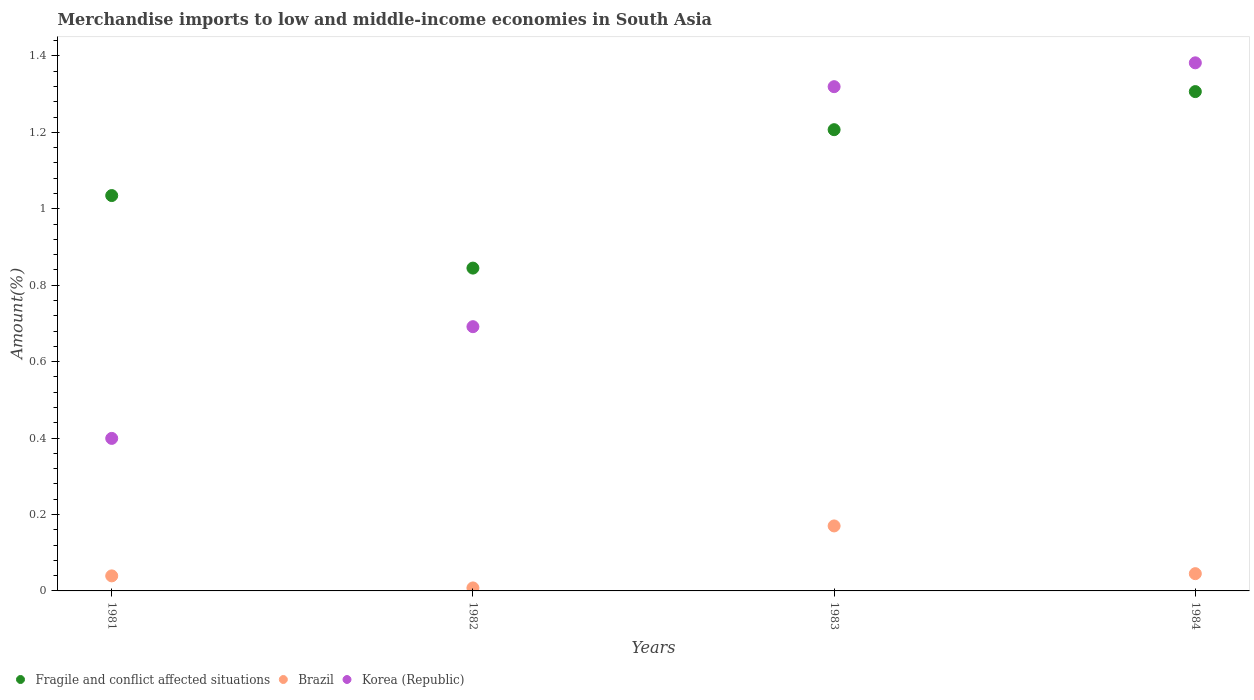What is the percentage of amount earned from merchandise imports in Brazil in 1984?
Offer a terse response. 0.05. Across all years, what is the maximum percentage of amount earned from merchandise imports in Korea (Republic)?
Your answer should be compact. 1.38. Across all years, what is the minimum percentage of amount earned from merchandise imports in Korea (Republic)?
Offer a very short reply. 0.4. In which year was the percentage of amount earned from merchandise imports in Brazil maximum?
Offer a terse response. 1983. What is the total percentage of amount earned from merchandise imports in Fragile and conflict affected situations in the graph?
Make the answer very short. 4.39. What is the difference between the percentage of amount earned from merchandise imports in Fragile and conflict affected situations in 1981 and that in 1984?
Your answer should be compact. -0.27. What is the difference between the percentage of amount earned from merchandise imports in Brazil in 1984 and the percentage of amount earned from merchandise imports in Fragile and conflict affected situations in 1981?
Your response must be concise. -0.99. What is the average percentage of amount earned from merchandise imports in Brazil per year?
Provide a succinct answer. 0.07. In the year 1981, what is the difference between the percentage of amount earned from merchandise imports in Korea (Republic) and percentage of amount earned from merchandise imports in Fragile and conflict affected situations?
Your answer should be very brief. -0.64. In how many years, is the percentage of amount earned from merchandise imports in Brazil greater than 1.16 %?
Make the answer very short. 0. What is the ratio of the percentage of amount earned from merchandise imports in Brazil in 1982 to that in 1984?
Keep it short and to the point. 0.17. Is the percentage of amount earned from merchandise imports in Fragile and conflict affected situations in 1981 less than that in 1982?
Provide a short and direct response. No. Is the difference between the percentage of amount earned from merchandise imports in Korea (Republic) in 1983 and 1984 greater than the difference between the percentage of amount earned from merchandise imports in Fragile and conflict affected situations in 1983 and 1984?
Keep it short and to the point. Yes. What is the difference between the highest and the second highest percentage of amount earned from merchandise imports in Fragile and conflict affected situations?
Give a very brief answer. 0.1. What is the difference between the highest and the lowest percentage of amount earned from merchandise imports in Fragile and conflict affected situations?
Keep it short and to the point. 0.46. Is the sum of the percentage of amount earned from merchandise imports in Fragile and conflict affected situations in 1983 and 1984 greater than the maximum percentage of amount earned from merchandise imports in Brazil across all years?
Offer a very short reply. Yes. Is it the case that in every year, the sum of the percentage of amount earned from merchandise imports in Fragile and conflict affected situations and percentage of amount earned from merchandise imports in Korea (Republic)  is greater than the percentage of amount earned from merchandise imports in Brazil?
Ensure brevity in your answer.  Yes. Is the percentage of amount earned from merchandise imports in Brazil strictly less than the percentage of amount earned from merchandise imports in Fragile and conflict affected situations over the years?
Offer a terse response. Yes. Does the graph contain any zero values?
Your answer should be very brief. No. Where does the legend appear in the graph?
Ensure brevity in your answer.  Bottom left. How many legend labels are there?
Give a very brief answer. 3. What is the title of the graph?
Provide a short and direct response. Merchandise imports to low and middle-income economies in South Asia. Does "Thailand" appear as one of the legend labels in the graph?
Make the answer very short. No. What is the label or title of the Y-axis?
Provide a succinct answer. Amount(%). What is the Amount(%) in Fragile and conflict affected situations in 1981?
Provide a succinct answer. 1.03. What is the Amount(%) in Brazil in 1981?
Provide a succinct answer. 0.04. What is the Amount(%) in Korea (Republic) in 1981?
Make the answer very short. 0.4. What is the Amount(%) of Fragile and conflict affected situations in 1982?
Your answer should be very brief. 0.84. What is the Amount(%) in Brazil in 1982?
Your answer should be very brief. 0.01. What is the Amount(%) of Korea (Republic) in 1982?
Give a very brief answer. 0.69. What is the Amount(%) in Fragile and conflict affected situations in 1983?
Provide a short and direct response. 1.21. What is the Amount(%) of Brazil in 1983?
Make the answer very short. 0.17. What is the Amount(%) in Korea (Republic) in 1983?
Your answer should be very brief. 1.32. What is the Amount(%) in Fragile and conflict affected situations in 1984?
Your response must be concise. 1.31. What is the Amount(%) of Brazil in 1984?
Your answer should be very brief. 0.05. What is the Amount(%) in Korea (Republic) in 1984?
Offer a terse response. 1.38. Across all years, what is the maximum Amount(%) in Fragile and conflict affected situations?
Offer a terse response. 1.31. Across all years, what is the maximum Amount(%) in Brazil?
Offer a very short reply. 0.17. Across all years, what is the maximum Amount(%) in Korea (Republic)?
Make the answer very short. 1.38. Across all years, what is the minimum Amount(%) of Fragile and conflict affected situations?
Ensure brevity in your answer.  0.84. Across all years, what is the minimum Amount(%) in Brazil?
Your answer should be very brief. 0.01. Across all years, what is the minimum Amount(%) in Korea (Republic)?
Keep it short and to the point. 0.4. What is the total Amount(%) of Fragile and conflict affected situations in the graph?
Ensure brevity in your answer.  4.39. What is the total Amount(%) in Brazil in the graph?
Your answer should be very brief. 0.26. What is the total Amount(%) in Korea (Republic) in the graph?
Provide a short and direct response. 3.79. What is the difference between the Amount(%) of Fragile and conflict affected situations in 1981 and that in 1982?
Ensure brevity in your answer.  0.19. What is the difference between the Amount(%) in Brazil in 1981 and that in 1982?
Your answer should be compact. 0.03. What is the difference between the Amount(%) of Korea (Republic) in 1981 and that in 1982?
Provide a short and direct response. -0.29. What is the difference between the Amount(%) in Fragile and conflict affected situations in 1981 and that in 1983?
Give a very brief answer. -0.17. What is the difference between the Amount(%) in Brazil in 1981 and that in 1983?
Offer a very short reply. -0.13. What is the difference between the Amount(%) in Korea (Republic) in 1981 and that in 1983?
Ensure brevity in your answer.  -0.92. What is the difference between the Amount(%) in Fragile and conflict affected situations in 1981 and that in 1984?
Make the answer very short. -0.27. What is the difference between the Amount(%) in Brazil in 1981 and that in 1984?
Offer a terse response. -0.01. What is the difference between the Amount(%) of Korea (Republic) in 1981 and that in 1984?
Ensure brevity in your answer.  -0.98. What is the difference between the Amount(%) of Fragile and conflict affected situations in 1982 and that in 1983?
Offer a terse response. -0.36. What is the difference between the Amount(%) of Brazil in 1982 and that in 1983?
Offer a very short reply. -0.16. What is the difference between the Amount(%) in Korea (Republic) in 1982 and that in 1983?
Your answer should be compact. -0.63. What is the difference between the Amount(%) of Fragile and conflict affected situations in 1982 and that in 1984?
Ensure brevity in your answer.  -0.46. What is the difference between the Amount(%) of Brazil in 1982 and that in 1984?
Ensure brevity in your answer.  -0.04. What is the difference between the Amount(%) of Korea (Republic) in 1982 and that in 1984?
Give a very brief answer. -0.69. What is the difference between the Amount(%) of Fragile and conflict affected situations in 1983 and that in 1984?
Offer a very short reply. -0.1. What is the difference between the Amount(%) in Brazil in 1983 and that in 1984?
Offer a very short reply. 0.12. What is the difference between the Amount(%) in Korea (Republic) in 1983 and that in 1984?
Give a very brief answer. -0.06. What is the difference between the Amount(%) in Fragile and conflict affected situations in 1981 and the Amount(%) in Brazil in 1982?
Provide a succinct answer. 1.03. What is the difference between the Amount(%) of Fragile and conflict affected situations in 1981 and the Amount(%) of Korea (Republic) in 1982?
Offer a terse response. 0.34. What is the difference between the Amount(%) in Brazil in 1981 and the Amount(%) in Korea (Republic) in 1982?
Keep it short and to the point. -0.65. What is the difference between the Amount(%) in Fragile and conflict affected situations in 1981 and the Amount(%) in Brazil in 1983?
Your answer should be compact. 0.86. What is the difference between the Amount(%) in Fragile and conflict affected situations in 1981 and the Amount(%) in Korea (Republic) in 1983?
Make the answer very short. -0.28. What is the difference between the Amount(%) in Brazil in 1981 and the Amount(%) in Korea (Republic) in 1983?
Make the answer very short. -1.28. What is the difference between the Amount(%) in Fragile and conflict affected situations in 1981 and the Amount(%) in Brazil in 1984?
Ensure brevity in your answer.  0.99. What is the difference between the Amount(%) of Fragile and conflict affected situations in 1981 and the Amount(%) of Korea (Republic) in 1984?
Your answer should be very brief. -0.35. What is the difference between the Amount(%) in Brazil in 1981 and the Amount(%) in Korea (Republic) in 1984?
Offer a very short reply. -1.34. What is the difference between the Amount(%) of Fragile and conflict affected situations in 1982 and the Amount(%) of Brazil in 1983?
Offer a terse response. 0.67. What is the difference between the Amount(%) in Fragile and conflict affected situations in 1982 and the Amount(%) in Korea (Republic) in 1983?
Provide a short and direct response. -0.47. What is the difference between the Amount(%) of Brazil in 1982 and the Amount(%) of Korea (Republic) in 1983?
Provide a short and direct response. -1.31. What is the difference between the Amount(%) of Fragile and conflict affected situations in 1982 and the Amount(%) of Brazil in 1984?
Provide a succinct answer. 0.8. What is the difference between the Amount(%) of Fragile and conflict affected situations in 1982 and the Amount(%) of Korea (Republic) in 1984?
Give a very brief answer. -0.54. What is the difference between the Amount(%) of Brazil in 1982 and the Amount(%) of Korea (Republic) in 1984?
Ensure brevity in your answer.  -1.37. What is the difference between the Amount(%) of Fragile and conflict affected situations in 1983 and the Amount(%) of Brazil in 1984?
Offer a very short reply. 1.16. What is the difference between the Amount(%) in Fragile and conflict affected situations in 1983 and the Amount(%) in Korea (Republic) in 1984?
Make the answer very short. -0.17. What is the difference between the Amount(%) of Brazil in 1983 and the Amount(%) of Korea (Republic) in 1984?
Your answer should be compact. -1.21. What is the average Amount(%) in Fragile and conflict affected situations per year?
Your answer should be compact. 1.1. What is the average Amount(%) in Brazil per year?
Your response must be concise. 0.07. What is the average Amount(%) of Korea (Republic) per year?
Your response must be concise. 0.95. In the year 1981, what is the difference between the Amount(%) in Fragile and conflict affected situations and Amount(%) in Brazil?
Ensure brevity in your answer.  1. In the year 1981, what is the difference between the Amount(%) of Fragile and conflict affected situations and Amount(%) of Korea (Republic)?
Make the answer very short. 0.64. In the year 1981, what is the difference between the Amount(%) of Brazil and Amount(%) of Korea (Republic)?
Make the answer very short. -0.36. In the year 1982, what is the difference between the Amount(%) in Fragile and conflict affected situations and Amount(%) in Brazil?
Provide a short and direct response. 0.84. In the year 1982, what is the difference between the Amount(%) in Fragile and conflict affected situations and Amount(%) in Korea (Republic)?
Offer a terse response. 0.15. In the year 1982, what is the difference between the Amount(%) in Brazil and Amount(%) in Korea (Republic)?
Provide a short and direct response. -0.68. In the year 1983, what is the difference between the Amount(%) of Fragile and conflict affected situations and Amount(%) of Korea (Republic)?
Provide a short and direct response. -0.11. In the year 1983, what is the difference between the Amount(%) of Brazil and Amount(%) of Korea (Republic)?
Your answer should be very brief. -1.15. In the year 1984, what is the difference between the Amount(%) of Fragile and conflict affected situations and Amount(%) of Brazil?
Provide a short and direct response. 1.26. In the year 1984, what is the difference between the Amount(%) of Fragile and conflict affected situations and Amount(%) of Korea (Republic)?
Provide a short and direct response. -0.08. In the year 1984, what is the difference between the Amount(%) in Brazil and Amount(%) in Korea (Republic)?
Keep it short and to the point. -1.34. What is the ratio of the Amount(%) in Fragile and conflict affected situations in 1981 to that in 1982?
Provide a short and direct response. 1.22. What is the ratio of the Amount(%) in Brazil in 1981 to that in 1982?
Your response must be concise. 5.03. What is the ratio of the Amount(%) in Korea (Republic) in 1981 to that in 1982?
Make the answer very short. 0.58. What is the ratio of the Amount(%) in Fragile and conflict affected situations in 1981 to that in 1983?
Your response must be concise. 0.86. What is the ratio of the Amount(%) in Brazil in 1981 to that in 1983?
Your answer should be very brief. 0.23. What is the ratio of the Amount(%) of Korea (Republic) in 1981 to that in 1983?
Your answer should be very brief. 0.3. What is the ratio of the Amount(%) of Fragile and conflict affected situations in 1981 to that in 1984?
Your response must be concise. 0.79. What is the ratio of the Amount(%) in Brazil in 1981 to that in 1984?
Keep it short and to the point. 0.87. What is the ratio of the Amount(%) in Korea (Republic) in 1981 to that in 1984?
Make the answer very short. 0.29. What is the ratio of the Amount(%) in Fragile and conflict affected situations in 1982 to that in 1983?
Offer a very short reply. 0.7. What is the ratio of the Amount(%) of Brazil in 1982 to that in 1983?
Your response must be concise. 0.05. What is the ratio of the Amount(%) in Korea (Republic) in 1982 to that in 1983?
Offer a terse response. 0.52. What is the ratio of the Amount(%) in Fragile and conflict affected situations in 1982 to that in 1984?
Give a very brief answer. 0.65. What is the ratio of the Amount(%) in Brazil in 1982 to that in 1984?
Keep it short and to the point. 0.17. What is the ratio of the Amount(%) of Korea (Republic) in 1982 to that in 1984?
Your answer should be compact. 0.5. What is the ratio of the Amount(%) of Fragile and conflict affected situations in 1983 to that in 1984?
Your answer should be very brief. 0.92. What is the ratio of the Amount(%) of Brazil in 1983 to that in 1984?
Offer a terse response. 3.77. What is the ratio of the Amount(%) in Korea (Republic) in 1983 to that in 1984?
Offer a very short reply. 0.95. What is the difference between the highest and the second highest Amount(%) of Fragile and conflict affected situations?
Your response must be concise. 0.1. What is the difference between the highest and the second highest Amount(%) in Brazil?
Your response must be concise. 0.12. What is the difference between the highest and the second highest Amount(%) in Korea (Republic)?
Offer a terse response. 0.06. What is the difference between the highest and the lowest Amount(%) of Fragile and conflict affected situations?
Offer a terse response. 0.46. What is the difference between the highest and the lowest Amount(%) in Brazil?
Provide a succinct answer. 0.16. What is the difference between the highest and the lowest Amount(%) of Korea (Republic)?
Provide a succinct answer. 0.98. 